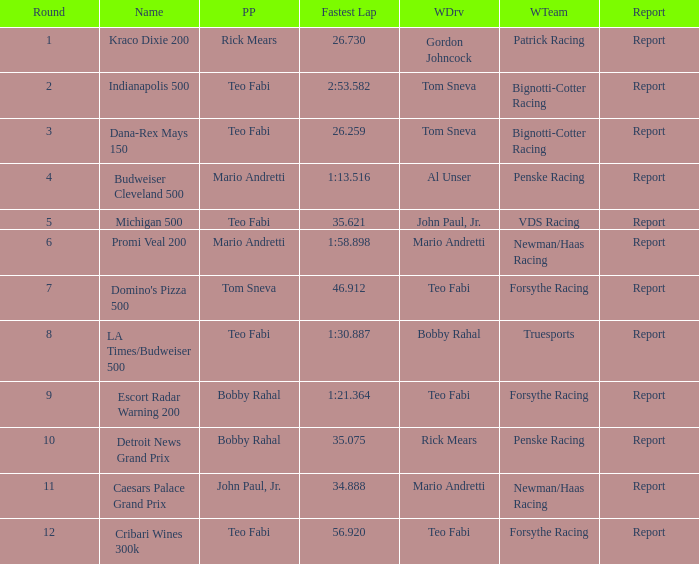How many reports are there in the race that Forsythe Racing won and Teo Fabi had the pole position in? 1.0. 